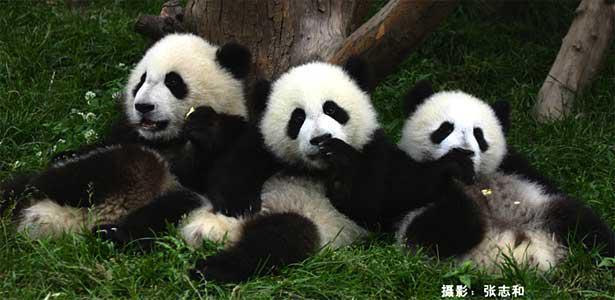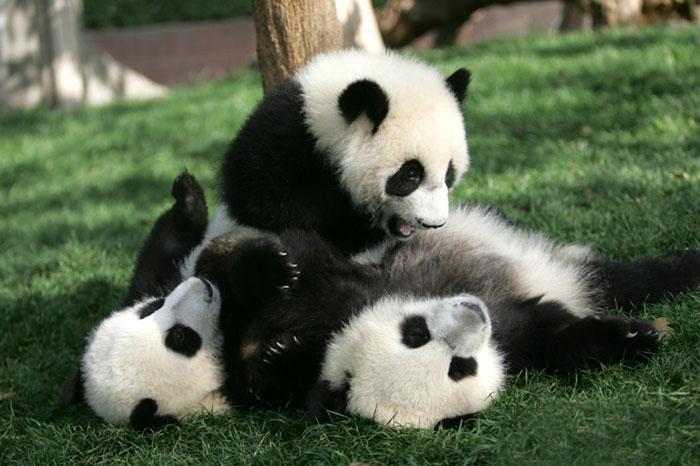The first image is the image on the left, the second image is the image on the right. For the images shown, is this caption "Each image shows a trio of pandas grouped closed together, and the right image shows pandas forming a pyramid shape on a ground of greenery." true? Answer yes or no. Yes. The first image is the image on the left, the second image is the image on the right. Considering the images on both sides, is "There are atleast 2 pandas in a tree" valid? Answer yes or no. No. 